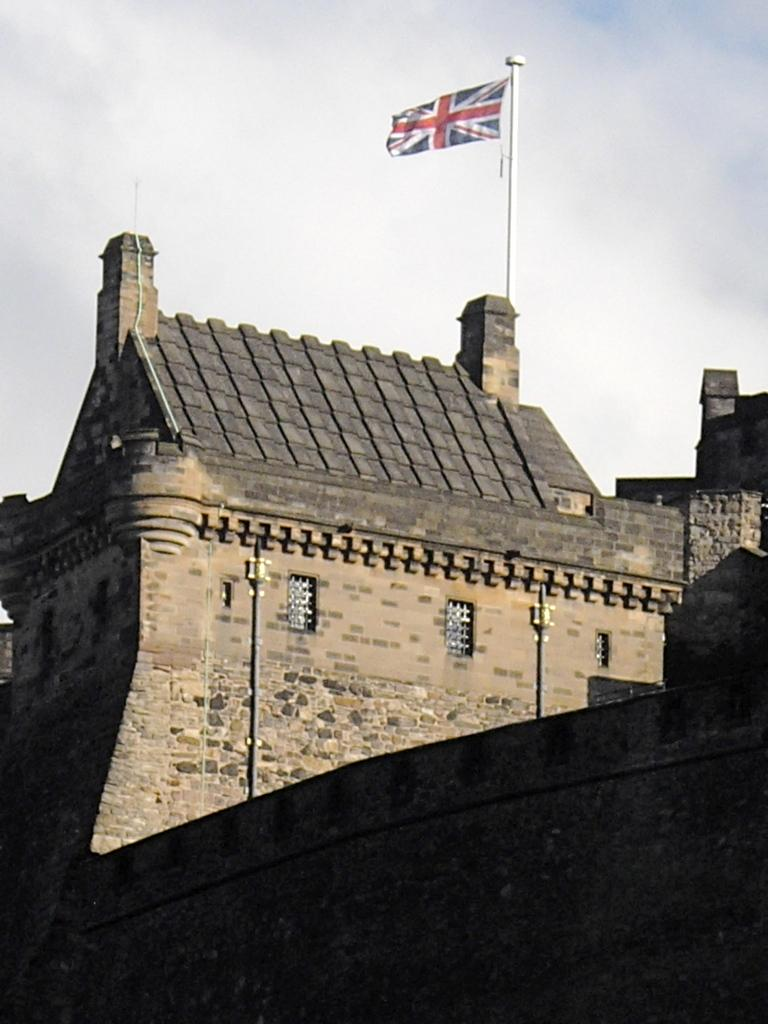What type of structure is present in the image? There is a building in the image. What feature of the building is mentioned in the facts? The building has windows. What else can be seen in the image besides the building? There are poles, a flag, a wall, and the sky visible in the image. Can you describe the flag in the image? There is a flag on a pole in the image. What part of the natural environment is visible in the image? The sky is visible in the image. How many brothers are sitting at the table in the image? There is no table or brothers present in the image. What type of performance is happening on the stage in the image? There is no stage or performance in the image. 